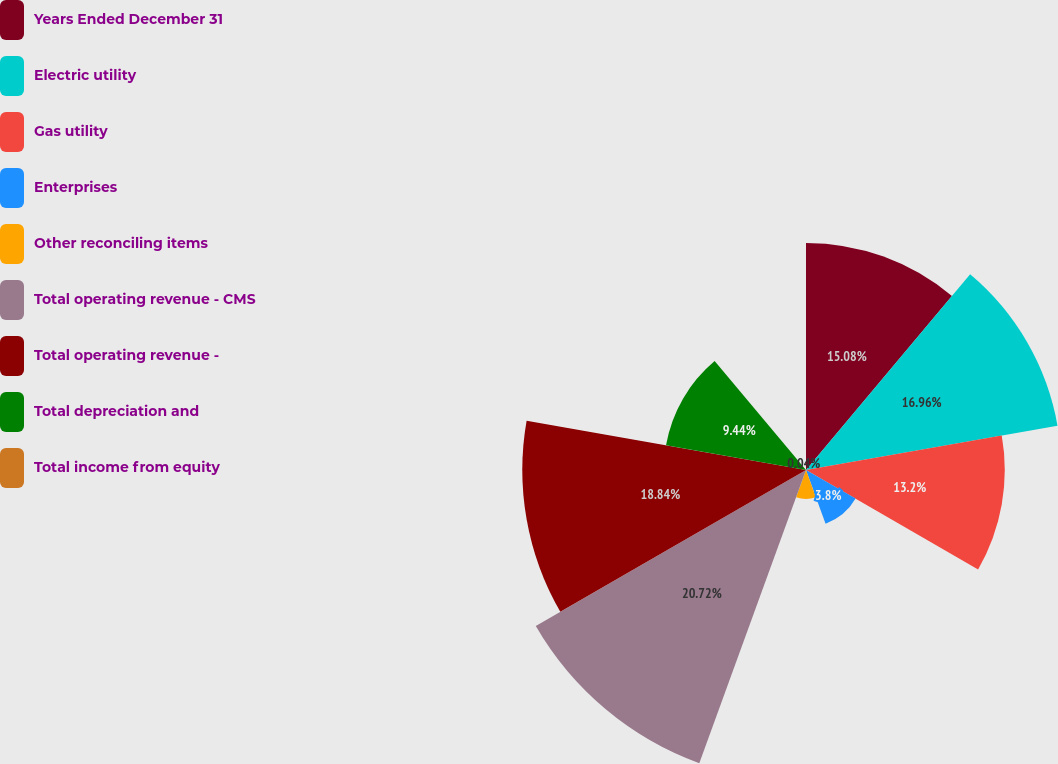Convert chart. <chart><loc_0><loc_0><loc_500><loc_500><pie_chart><fcel>Years Ended December 31<fcel>Electric utility<fcel>Gas utility<fcel>Enterprises<fcel>Other reconciling items<fcel>Total operating revenue - CMS<fcel>Total operating revenue -<fcel>Total depreciation and<fcel>Total income from equity<nl><fcel>15.08%<fcel>16.96%<fcel>13.2%<fcel>3.8%<fcel>1.92%<fcel>20.72%<fcel>18.84%<fcel>9.44%<fcel>0.04%<nl></chart> 